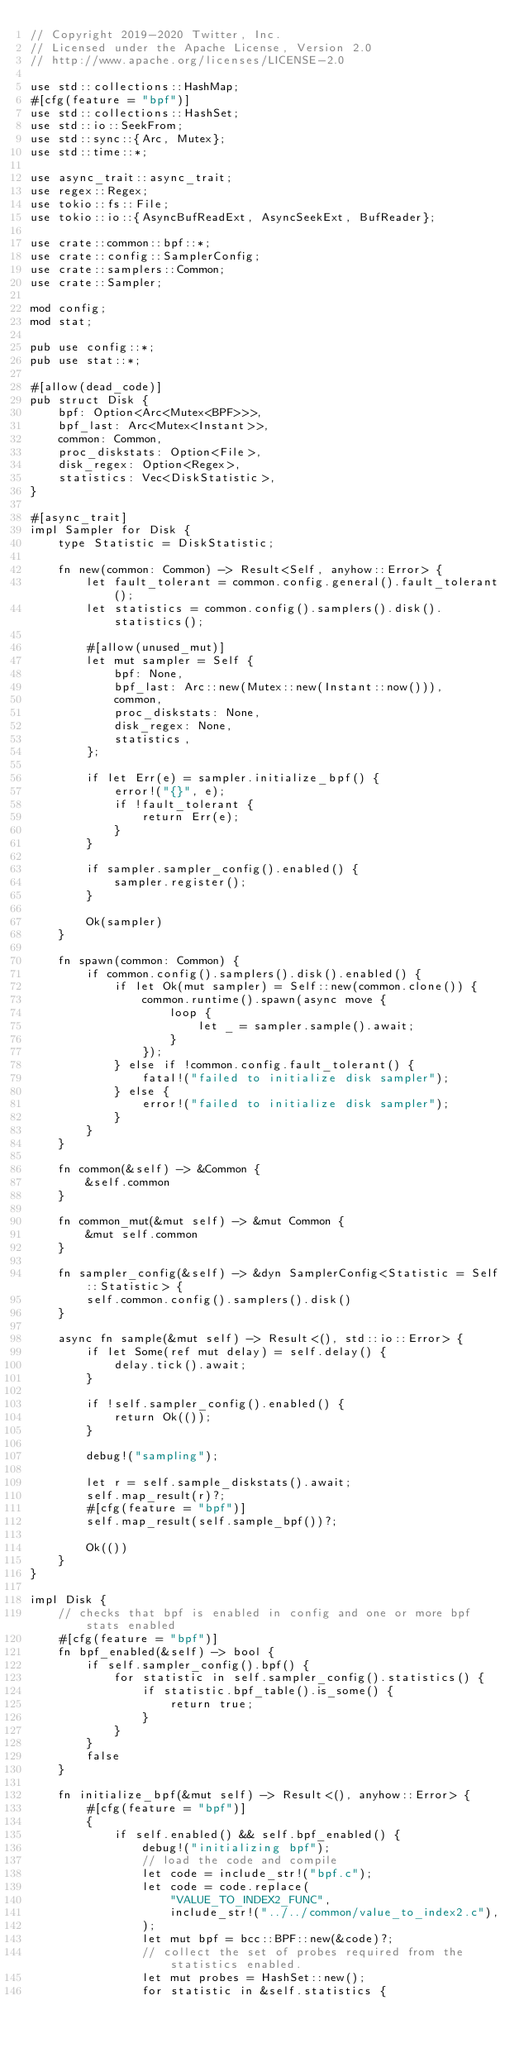Convert code to text. <code><loc_0><loc_0><loc_500><loc_500><_Rust_>// Copyright 2019-2020 Twitter, Inc.
// Licensed under the Apache License, Version 2.0
// http://www.apache.org/licenses/LICENSE-2.0

use std::collections::HashMap;
#[cfg(feature = "bpf")]
use std::collections::HashSet;
use std::io::SeekFrom;
use std::sync::{Arc, Mutex};
use std::time::*;

use async_trait::async_trait;
use regex::Regex;
use tokio::fs::File;
use tokio::io::{AsyncBufReadExt, AsyncSeekExt, BufReader};

use crate::common::bpf::*;
use crate::config::SamplerConfig;
use crate::samplers::Common;
use crate::Sampler;

mod config;
mod stat;

pub use config::*;
pub use stat::*;

#[allow(dead_code)]
pub struct Disk {
    bpf: Option<Arc<Mutex<BPF>>>,
    bpf_last: Arc<Mutex<Instant>>,
    common: Common,
    proc_diskstats: Option<File>,
    disk_regex: Option<Regex>,
    statistics: Vec<DiskStatistic>,
}

#[async_trait]
impl Sampler for Disk {
    type Statistic = DiskStatistic;

    fn new(common: Common) -> Result<Self, anyhow::Error> {
        let fault_tolerant = common.config.general().fault_tolerant();
        let statistics = common.config().samplers().disk().statistics();

        #[allow(unused_mut)]
        let mut sampler = Self {
            bpf: None,
            bpf_last: Arc::new(Mutex::new(Instant::now())),
            common,
            proc_diskstats: None,
            disk_regex: None,
            statistics,
        };

        if let Err(e) = sampler.initialize_bpf() {
            error!("{}", e);
            if !fault_tolerant {
                return Err(e);
            }
        }

        if sampler.sampler_config().enabled() {
            sampler.register();
        }

        Ok(sampler)
    }

    fn spawn(common: Common) {
        if common.config().samplers().disk().enabled() {
            if let Ok(mut sampler) = Self::new(common.clone()) {
                common.runtime().spawn(async move {
                    loop {
                        let _ = sampler.sample().await;
                    }
                });
            } else if !common.config.fault_tolerant() {
                fatal!("failed to initialize disk sampler");
            } else {
                error!("failed to initialize disk sampler");
            }
        }
    }

    fn common(&self) -> &Common {
        &self.common
    }

    fn common_mut(&mut self) -> &mut Common {
        &mut self.common
    }

    fn sampler_config(&self) -> &dyn SamplerConfig<Statistic = Self::Statistic> {
        self.common.config().samplers().disk()
    }

    async fn sample(&mut self) -> Result<(), std::io::Error> {
        if let Some(ref mut delay) = self.delay() {
            delay.tick().await;
        }

        if !self.sampler_config().enabled() {
            return Ok(());
        }

        debug!("sampling");

        let r = self.sample_diskstats().await;
        self.map_result(r)?;
        #[cfg(feature = "bpf")]
        self.map_result(self.sample_bpf())?;

        Ok(())
    }
}

impl Disk {
    // checks that bpf is enabled in config and one or more bpf stats enabled
    #[cfg(feature = "bpf")]
    fn bpf_enabled(&self) -> bool {
        if self.sampler_config().bpf() {
            for statistic in self.sampler_config().statistics() {
                if statistic.bpf_table().is_some() {
                    return true;
                }
            }
        }
        false
    }

    fn initialize_bpf(&mut self) -> Result<(), anyhow::Error> {
        #[cfg(feature = "bpf")]
        {
            if self.enabled() && self.bpf_enabled() {
                debug!("initializing bpf");
                // load the code and compile
                let code = include_str!("bpf.c");
                let code = code.replace(
                    "VALUE_TO_INDEX2_FUNC",
                    include_str!("../../common/value_to_index2.c"),
                );
                let mut bpf = bcc::BPF::new(&code)?;
                // collect the set of probes required from the statistics enabled.
                let mut probes = HashSet::new();
                for statistic in &self.statistics {</code> 